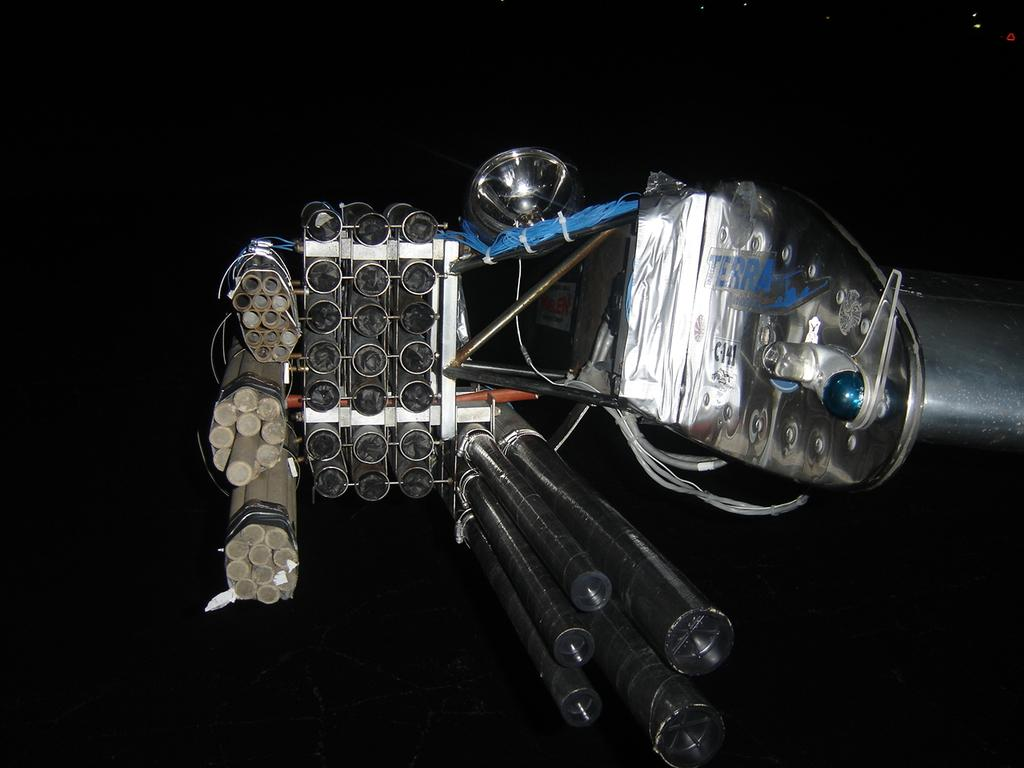What type of objects can be seen in the image? There are pipes, iron rods, and cables in the image. Can you describe the object with other things attached to it? The object with other things attached to it is not specified in the facts, but we can see that there are pipes, iron rods, and cables attached to it. What is the color of the background in the image? The background of the image appears dark. Can you tell me how many giraffes are visible in the image? There are no giraffes present in the image. What type of soda is being served in the image? There is no soda present in the image. 